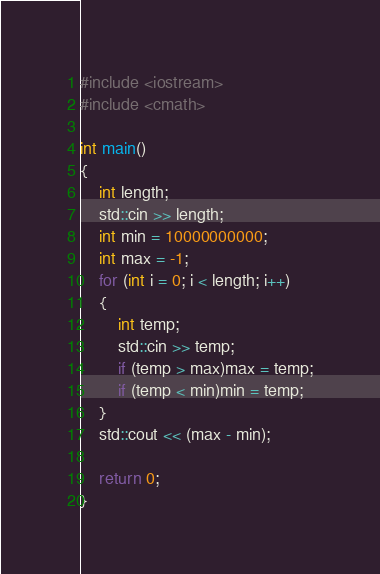Convert code to text. <code><loc_0><loc_0><loc_500><loc_500><_C++_>
#include <iostream>
#include <cmath>

int main()
{
	int length;
	std::cin >> length;
	int min = 10000000000;
	int max = -1;
	for (int i = 0; i < length; i++)
	{
		int temp;
		std::cin >> temp;
		if (temp > max)max = temp;
		if (temp < min)min = temp;
	}
	std::cout << (max - min);

	return 0;
}</code> 